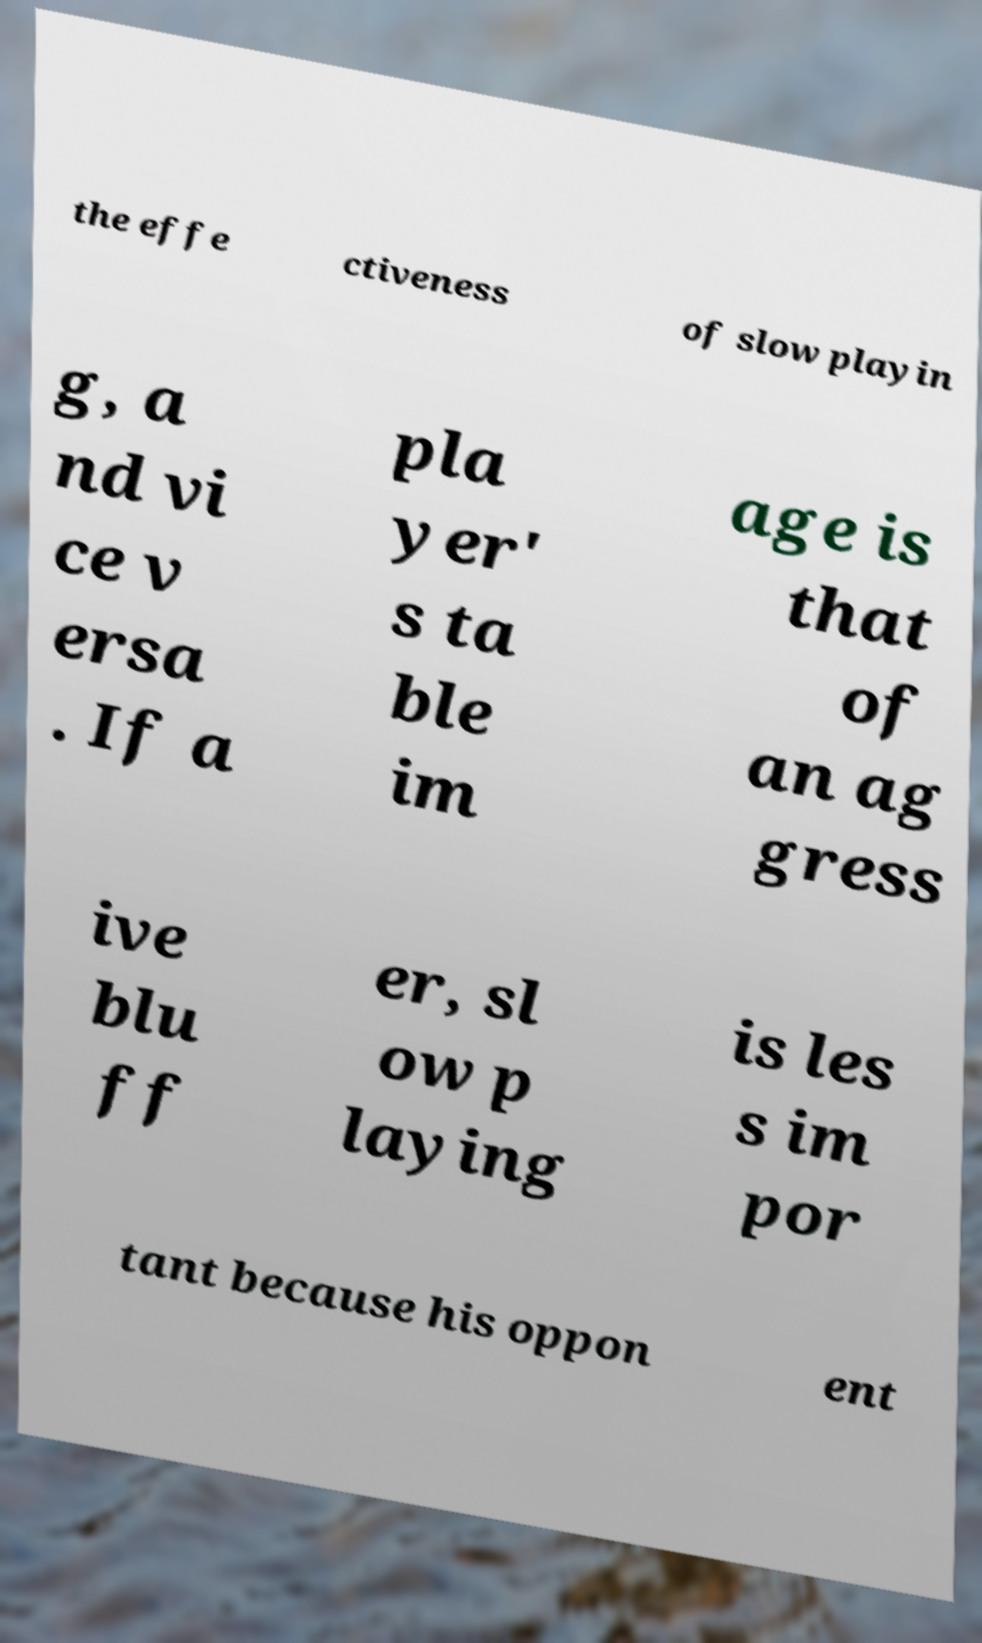There's text embedded in this image that I need extracted. Can you transcribe it verbatim? the effe ctiveness of slow playin g, a nd vi ce v ersa . If a pla yer' s ta ble im age is that of an ag gress ive blu ff er, sl ow p laying is les s im por tant because his oppon ent 